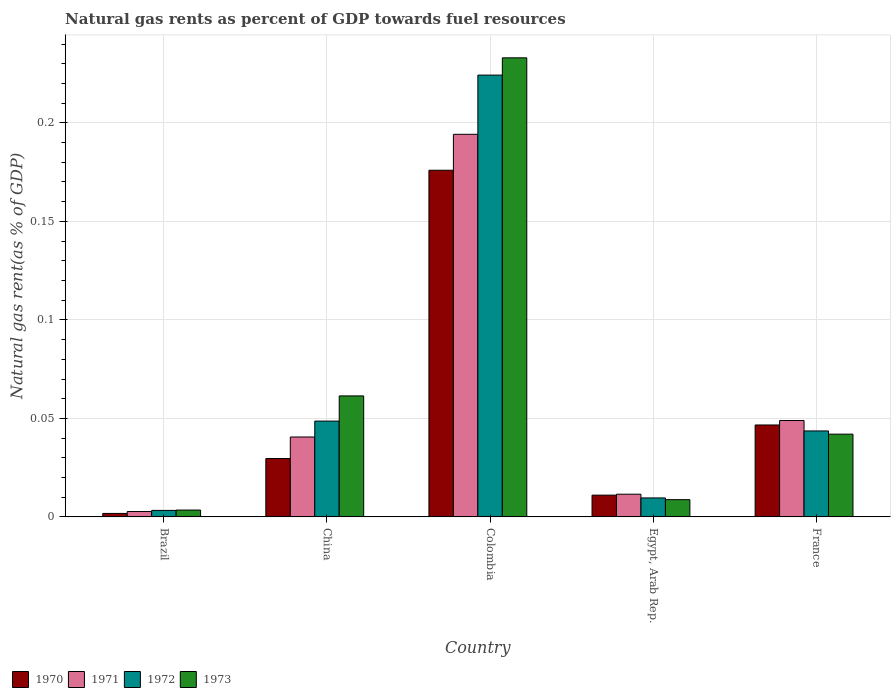How many different coloured bars are there?
Your answer should be very brief. 4. Are the number of bars on each tick of the X-axis equal?
Your response must be concise. Yes. How many bars are there on the 3rd tick from the right?
Ensure brevity in your answer.  4. What is the label of the 5th group of bars from the left?
Your answer should be very brief. France. What is the natural gas rent in 1972 in China?
Provide a succinct answer. 0.05. Across all countries, what is the maximum natural gas rent in 1972?
Your answer should be very brief. 0.22. Across all countries, what is the minimum natural gas rent in 1971?
Give a very brief answer. 0. In which country was the natural gas rent in 1970 maximum?
Give a very brief answer. Colombia. In which country was the natural gas rent in 1971 minimum?
Provide a short and direct response. Brazil. What is the total natural gas rent in 1970 in the graph?
Give a very brief answer. 0.27. What is the difference between the natural gas rent in 1970 in Brazil and that in France?
Offer a terse response. -0.04. What is the difference between the natural gas rent in 1971 in France and the natural gas rent in 1970 in Brazil?
Keep it short and to the point. 0.05. What is the average natural gas rent in 1970 per country?
Your answer should be compact. 0.05. What is the difference between the natural gas rent of/in 1971 and natural gas rent of/in 1973 in Egypt, Arab Rep.?
Offer a very short reply. 0. What is the ratio of the natural gas rent in 1972 in Egypt, Arab Rep. to that in France?
Provide a short and direct response. 0.22. Is the natural gas rent in 1973 in China less than that in Egypt, Arab Rep.?
Make the answer very short. No. What is the difference between the highest and the second highest natural gas rent in 1970?
Offer a terse response. 0.15. What is the difference between the highest and the lowest natural gas rent in 1973?
Offer a terse response. 0.23. In how many countries, is the natural gas rent in 1973 greater than the average natural gas rent in 1973 taken over all countries?
Your response must be concise. 1. Is the sum of the natural gas rent in 1972 in Egypt, Arab Rep. and France greater than the maximum natural gas rent in 1973 across all countries?
Your response must be concise. No. Is it the case that in every country, the sum of the natural gas rent in 1972 and natural gas rent in 1973 is greater than the sum of natural gas rent in 1970 and natural gas rent in 1971?
Give a very brief answer. No. What does the 4th bar from the left in Egypt, Arab Rep. represents?
Provide a short and direct response. 1973. What does the 4th bar from the right in Colombia represents?
Provide a succinct answer. 1970. Is it the case that in every country, the sum of the natural gas rent in 1972 and natural gas rent in 1973 is greater than the natural gas rent in 1971?
Provide a short and direct response. Yes. Are all the bars in the graph horizontal?
Offer a very short reply. No. Are the values on the major ticks of Y-axis written in scientific E-notation?
Your response must be concise. No. Does the graph contain any zero values?
Give a very brief answer. No. Where does the legend appear in the graph?
Provide a succinct answer. Bottom left. How are the legend labels stacked?
Give a very brief answer. Horizontal. What is the title of the graph?
Make the answer very short. Natural gas rents as percent of GDP towards fuel resources. Does "2000" appear as one of the legend labels in the graph?
Make the answer very short. No. What is the label or title of the Y-axis?
Keep it short and to the point. Natural gas rent(as % of GDP). What is the Natural gas rent(as % of GDP) of 1970 in Brazil?
Offer a terse response. 0. What is the Natural gas rent(as % of GDP) in 1971 in Brazil?
Your answer should be compact. 0. What is the Natural gas rent(as % of GDP) of 1972 in Brazil?
Provide a succinct answer. 0. What is the Natural gas rent(as % of GDP) in 1973 in Brazil?
Offer a terse response. 0. What is the Natural gas rent(as % of GDP) of 1970 in China?
Offer a terse response. 0.03. What is the Natural gas rent(as % of GDP) in 1971 in China?
Your response must be concise. 0.04. What is the Natural gas rent(as % of GDP) of 1972 in China?
Provide a succinct answer. 0.05. What is the Natural gas rent(as % of GDP) of 1973 in China?
Offer a terse response. 0.06. What is the Natural gas rent(as % of GDP) in 1970 in Colombia?
Your answer should be compact. 0.18. What is the Natural gas rent(as % of GDP) of 1971 in Colombia?
Provide a succinct answer. 0.19. What is the Natural gas rent(as % of GDP) in 1972 in Colombia?
Ensure brevity in your answer.  0.22. What is the Natural gas rent(as % of GDP) in 1973 in Colombia?
Your answer should be very brief. 0.23. What is the Natural gas rent(as % of GDP) in 1970 in Egypt, Arab Rep.?
Offer a very short reply. 0.01. What is the Natural gas rent(as % of GDP) in 1971 in Egypt, Arab Rep.?
Offer a very short reply. 0.01. What is the Natural gas rent(as % of GDP) in 1972 in Egypt, Arab Rep.?
Provide a short and direct response. 0.01. What is the Natural gas rent(as % of GDP) in 1973 in Egypt, Arab Rep.?
Offer a terse response. 0.01. What is the Natural gas rent(as % of GDP) of 1970 in France?
Keep it short and to the point. 0.05. What is the Natural gas rent(as % of GDP) of 1971 in France?
Offer a very short reply. 0.05. What is the Natural gas rent(as % of GDP) of 1972 in France?
Offer a very short reply. 0.04. What is the Natural gas rent(as % of GDP) of 1973 in France?
Give a very brief answer. 0.04. Across all countries, what is the maximum Natural gas rent(as % of GDP) in 1970?
Provide a short and direct response. 0.18. Across all countries, what is the maximum Natural gas rent(as % of GDP) of 1971?
Give a very brief answer. 0.19. Across all countries, what is the maximum Natural gas rent(as % of GDP) in 1972?
Ensure brevity in your answer.  0.22. Across all countries, what is the maximum Natural gas rent(as % of GDP) of 1973?
Keep it short and to the point. 0.23. Across all countries, what is the minimum Natural gas rent(as % of GDP) of 1970?
Your answer should be compact. 0. Across all countries, what is the minimum Natural gas rent(as % of GDP) in 1971?
Give a very brief answer. 0. Across all countries, what is the minimum Natural gas rent(as % of GDP) in 1972?
Ensure brevity in your answer.  0. Across all countries, what is the minimum Natural gas rent(as % of GDP) in 1973?
Your response must be concise. 0. What is the total Natural gas rent(as % of GDP) in 1970 in the graph?
Your answer should be very brief. 0.27. What is the total Natural gas rent(as % of GDP) of 1971 in the graph?
Make the answer very short. 0.3. What is the total Natural gas rent(as % of GDP) in 1972 in the graph?
Ensure brevity in your answer.  0.33. What is the total Natural gas rent(as % of GDP) in 1973 in the graph?
Keep it short and to the point. 0.35. What is the difference between the Natural gas rent(as % of GDP) of 1970 in Brazil and that in China?
Your answer should be compact. -0.03. What is the difference between the Natural gas rent(as % of GDP) of 1971 in Brazil and that in China?
Make the answer very short. -0.04. What is the difference between the Natural gas rent(as % of GDP) in 1972 in Brazil and that in China?
Your answer should be compact. -0.05. What is the difference between the Natural gas rent(as % of GDP) in 1973 in Brazil and that in China?
Provide a short and direct response. -0.06. What is the difference between the Natural gas rent(as % of GDP) in 1970 in Brazil and that in Colombia?
Offer a terse response. -0.17. What is the difference between the Natural gas rent(as % of GDP) in 1971 in Brazil and that in Colombia?
Offer a terse response. -0.19. What is the difference between the Natural gas rent(as % of GDP) of 1972 in Brazil and that in Colombia?
Provide a short and direct response. -0.22. What is the difference between the Natural gas rent(as % of GDP) of 1973 in Brazil and that in Colombia?
Provide a succinct answer. -0.23. What is the difference between the Natural gas rent(as % of GDP) in 1970 in Brazil and that in Egypt, Arab Rep.?
Make the answer very short. -0.01. What is the difference between the Natural gas rent(as % of GDP) of 1971 in Brazil and that in Egypt, Arab Rep.?
Make the answer very short. -0.01. What is the difference between the Natural gas rent(as % of GDP) in 1972 in Brazil and that in Egypt, Arab Rep.?
Offer a terse response. -0.01. What is the difference between the Natural gas rent(as % of GDP) in 1973 in Brazil and that in Egypt, Arab Rep.?
Your answer should be very brief. -0.01. What is the difference between the Natural gas rent(as % of GDP) of 1970 in Brazil and that in France?
Ensure brevity in your answer.  -0.04. What is the difference between the Natural gas rent(as % of GDP) of 1971 in Brazil and that in France?
Provide a succinct answer. -0.05. What is the difference between the Natural gas rent(as % of GDP) of 1972 in Brazil and that in France?
Ensure brevity in your answer.  -0.04. What is the difference between the Natural gas rent(as % of GDP) of 1973 in Brazil and that in France?
Provide a succinct answer. -0.04. What is the difference between the Natural gas rent(as % of GDP) of 1970 in China and that in Colombia?
Ensure brevity in your answer.  -0.15. What is the difference between the Natural gas rent(as % of GDP) of 1971 in China and that in Colombia?
Keep it short and to the point. -0.15. What is the difference between the Natural gas rent(as % of GDP) of 1972 in China and that in Colombia?
Make the answer very short. -0.18. What is the difference between the Natural gas rent(as % of GDP) of 1973 in China and that in Colombia?
Make the answer very short. -0.17. What is the difference between the Natural gas rent(as % of GDP) of 1970 in China and that in Egypt, Arab Rep.?
Your response must be concise. 0.02. What is the difference between the Natural gas rent(as % of GDP) of 1971 in China and that in Egypt, Arab Rep.?
Offer a very short reply. 0.03. What is the difference between the Natural gas rent(as % of GDP) of 1972 in China and that in Egypt, Arab Rep.?
Provide a succinct answer. 0.04. What is the difference between the Natural gas rent(as % of GDP) of 1973 in China and that in Egypt, Arab Rep.?
Offer a very short reply. 0.05. What is the difference between the Natural gas rent(as % of GDP) in 1970 in China and that in France?
Offer a terse response. -0.02. What is the difference between the Natural gas rent(as % of GDP) of 1971 in China and that in France?
Provide a succinct answer. -0.01. What is the difference between the Natural gas rent(as % of GDP) in 1972 in China and that in France?
Your answer should be compact. 0.01. What is the difference between the Natural gas rent(as % of GDP) of 1973 in China and that in France?
Your answer should be compact. 0.02. What is the difference between the Natural gas rent(as % of GDP) in 1970 in Colombia and that in Egypt, Arab Rep.?
Provide a succinct answer. 0.16. What is the difference between the Natural gas rent(as % of GDP) of 1971 in Colombia and that in Egypt, Arab Rep.?
Your answer should be compact. 0.18. What is the difference between the Natural gas rent(as % of GDP) of 1972 in Colombia and that in Egypt, Arab Rep.?
Give a very brief answer. 0.21. What is the difference between the Natural gas rent(as % of GDP) of 1973 in Colombia and that in Egypt, Arab Rep.?
Provide a succinct answer. 0.22. What is the difference between the Natural gas rent(as % of GDP) of 1970 in Colombia and that in France?
Offer a very short reply. 0.13. What is the difference between the Natural gas rent(as % of GDP) in 1971 in Colombia and that in France?
Offer a very short reply. 0.15. What is the difference between the Natural gas rent(as % of GDP) of 1972 in Colombia and that in France?
Provide a short and direct response. 0.18. What is the difference between the Natural gas rent(as % of GDP) in 1973 in Colombia and that in France?
Your answer should be very brief. 0.19. What is the difference between the Natural gas rent(as % of GDP) of 1970 in Egypt, Arab Rep. and that in France?
Offer a very short reply. -0.04. What is the difference between the Natural gas rent(as % of GDP) in 1971 in Egypt, Arab Rep. and that in France?
Your response must be concise. -0.04. What is the difference between the Natural gas rent(as % of GDP) in 1972 in Egypt, Arab Rep. and that in France?
Offer a very short reply. -0.03. What is the difference between the Natural gas rent(as % of GDP) in 1973 in Egypt, Arab Rep. and that in France?
Provide a succinct answer. -0.03. What is the difference between the Natural gas rent(as % of GDP) in 1970 in Brazil and the Natural gas rent(as % of GDP) in 1971 in China?
Your response must be concise. -0.04. What is the difference between the Natural gas rent(as % of GDP) in 1970 in Brazil and the Natural gas rent(as % of GDP) in 1972 in China?
Give a very brief answer. -0.05. What is the difference between the Natural gas rent(as % of GDP) in 1970 in Brazil and the Natural gas rent(as % of GDP) in 1973 in China?
Provide a short and direct response. -0.06. What is the difference between the Natural gas rent(as % of GDP) of 1971 in Brazil and the Natural gas rent(as % of GDP) of 1972 in China?
Your answer should be compact. -0.05. What is the difference between the Natural gas rent(as % of GDP) in 1971 in Brazil and the Natural gas rent(as % of GDP) in 1973 in China?
Keep it short and to the point. -0.06. What is the difference between the Natural gas rent(as % of GDP) of 1972 in Brazil and the Natural gas rent(as % of GDP) of 1973 in China?
Your answer should be very brief. -0.06. What is the difference between the Natural gas rent(as % of GDP) in 1970 in Brazil and the Natural gas rent(as % of GDP) in 1971 in Colombia?
Your response must be concise. -0.19. What is the difference between the Natural gas rent(as % of GDP) in 1970 in Brazil and the Natural gas rent(as % of GDP) in 1972 in Colombia?
Offer a terse response. -0.22. What is the difference between the Natural gas rent(as % of GDP) of 1970 in Brazil and the Natural gas rent(as % of GDP) of 1973 in Colombia?
Keep it short and to the point. -0.23. What is the difference between the Natural gas rent(as % of GDP) of 1971 in Brazil and the Natural gas rent(as % of GDP) of 1972 in Colombia?
Give a very brief answer. -0.22. What is the difference between the Natural gas rent(as % of GDP) in 1971 in Brazil and the Natural gas rent(as % of GDP) in 1973 in Colombia?
Offer a very short reply. -0.23. What is the difference between the Natural gas rent(as % of GDP) of 1972 in Brazil and the Natural gas rent(as % of GDP) of 1973 in Colombia?
Give a very brief answer. -0.23. What is the difference between the Natural gas rent(as % of GDP) of 1970 in Brazil and the Natural gas rent(as % of GDP) of 1971 in Egypt, Arab Rep.?
Your response must be concise. -0.01. What is the difference between the Natural gas rent(as % of GDP) in 1970 in Brazil and the Natural gas rent(as % of GDP) in 1972 in Egypt, Arab Rep.?
Keep it short and to the point. -0.01. What is the difference between the Natural gas rent(as % of GDP) of 1970 in Brazil and the Natural gas rent(as % of GDP) of 1973 in Egypt, Arab Rep.?
Ensure brevity in your answer.  -0.01. What is the difference between the Natural gas rent(as % of GDP) of 1971 in Brazil and the Natural gas rent(as % of GDP) of 1972 in Egypt, Arab Rep.?
Your answer should be very brief. -0.01. What is the difference between the Natural gas rent(as % of GDP) in 1971 in Brazil and the Natural gas rent(as % of GDP) in 1973 in Egypt, Arab Rep.?
Your answer should be compact. -0.01. What is the difference between the Natural gas rent(as % of GDP) in 1972 in Brazil and the Natural gas rent(as % of GDP) in 1973 in Egypt, Arab Rep.?
Give a very brief answer. -0.01. What is the difference between the Natural gas rent(as % of GDP) of 1970 in Brazil and the Natural gas rent(as % of GDP) of 1971 in France?
Provide a short and direct response. -0.05. What is the difference between the Natural gas rent(as % of GDP) in 1970 in Brazil and the Natural gas rent(as % of GDP) in 1972 in France?
Your answer should be very brief. -0.04. What is the difference between the Natural gas rent(as % of GDP) of 1970 in Brazil and the Natural gas rent(as % of GDP) of 1973 in France?
Make the answer very short. -0.04. What is the difference between the Natural gas rent(as % of GDP) in 1971 in Brazil and the Natural gas rent(as % of GDP) in 1972 in France?
Your response must be concise. -0.04. What is the difference between the Natural gas rent(as % of GDP) of 1971 in Brazil and the Natural gas rent(as % of GDP) of 1973 in France?
Provide a succinct answer. -0.04. What is the difference between the Natural gas rent(as % of GDP) in 1972 in Brazil and the Natural gas rent(as % of GDP) in 1973 in France?
Make the answer very short. -0.04. What is the difference between the Natural gas rent(as % of GDP) in 1970 in China and the Natural gas rent(as % of GDP) in 1971 in Colombia?
Make the answer very short. -0.16. What is the difference between the Natural gas rent(as % of GDP) in 1970 in China and the Natural gas rent(as % of GDP) in 1972 in Colombia?
Keep it short and to the point. -0.19. What is the difference between the Natural gas rent(as % of GDP) in 1970 in China and the Natural gas rent(as % of GDP) in 1973 in Colombia?
Make the answer very short. -0.2. What is the difference between the Natural gas rent(as % of GDP) of 1971 in China and the Natural gas rent(as % of GDP) of 1972 in Colombia?
Keep it short and to the point. -0.18. What is the difference between the Natural gas rent(as % of GDP) of 1971 in China and the Natural gas rent(as % of GDP) of 1973 in Colombia?
Your answer should be very brief. -0.19. What is the difference between the Natural gas rent(as % of GDP) of 1972 in China and the Natural gas rent(as % of GDP) of 1973 in Colombia?
Give a very brief answer. -0.18. What is the difference between the Natural gas rent(as % of GDP) in 1970 in China and the Natural gas rent(as % of GDP) in 1971 in Egypt, Arab Rep.?
Provide a succinct answer. 0.02. What is the difference between the Natural gas rent(as % of GDP) of 1970 in China and the Natural gas rent(as % of GDP) of 1972 in Egypt, Arab Rep.?
Your answer should be compact. 0.02. What is the difference between the Natural gas rent(as % of GDP) of 1970 in China and the Natural gas rent(as % of GDP) of 1973 in Egypt, Arab Rep.?
Provide a short and direct response. 0.02. What is the difference between the Natural gas rent(as % of GDP) of 1971 in China and the Natural gas rent(as % of GDP) of 1972 in Egypt, Arab Rep.?
Offer a terse response. 0.03. What is the difference between the Natural gas rent(as % of GDP) in 1971 in China and the Natural gas rent(as % of GDP) in 1973 in Egypt, Arab Rep.?
Keep it short and to the point. 0.03. What is the difference between the Natural gas rent(as % of GDP) of 1972 in China and the Natural gas rent(as % of GDP) of 1973 in Egypt, Arab Rep.?
Make the answer very short. 0.04. What is the difference between the Natural gas rent(as % of GDP) in 1970 in China and the Natural gas rent(as % of GDP) in 1971 in France?
Offer a terse response. -0.02. What is the difference between the Natural gas rent(as % of GDP) of 1970 in China and the Natural gas rent(as % of GDP) of 1972 in France?
Offer a terse response. -0.01. What is the difference between the Natural gas rent(as % of GDP) of 1970 in China and the Natural gas rent(as % of GDP) of 1973 in France?
Offer a terse response. -0.01. What is the difference between the Natural gas rent(as % of GDP) in 1971 in China and the Natural gas rent(as % of GDP) in 1972 in France?
Give a very brief answer. -0. What is the difference between the Natural gas rent(as % of GDP) of 1971 in China and the Natural gas rent(as % of GDP) of 1973 in France?
Offer a terse response. -0. What is the difference between the Natural gas rent(as % of GDP) of 1972 in China and the Natural gas rent(as % of GDP) of 1973 in France?
Give a very brief answer. 0.01. What is the difference between the Natural gas rent(as % of GDP) of 1970 in Colombia and the Natural gas rent(as % of GDP) of 1971 in Egypt, Arab Rep.?
Your answer should be compact. 0.16. What is the difference between the Natural gas rent(as % of GDP) in 1970 in Colombia and the Natural gas rent(as % of GDP) in 1972 in Egypt, Arab Rep.?
Your answer should be compact. 0.17. What is the difference between the Natural gas rent(as % of GDP) in 1970 in Colombia and the Natural gas rent(as % of GDP) in 1973 in Egypt, Arab Rep.?
Offer a very short reply. 0.17. What is the difference between the Natural gas rent(as % of GDP) in 1971 in Colombia and the Natural gas rent(as % of GDP) in 1972 in Egypt, Arab Rep.?
Provide a short and direct response. 0.18. What is the difference between the Natural gas rent(as % of GDP) in 1971 in Colombia and the Natural gas rent(as % of GDP) in 1973 in Egypt, Arab Rep.?
Provide a succinct answer. 0.19. What is the difference between the Natural gas rent(as % of GDP) in 1972 in Colombia and the Natural gas rent(as % of GDP) in 1973 in Egypt, Arab Rep.?
Ensure brevity in your answer.  0.22. What is the difference between the Natural gas rent(as % of GDP) in 1970 in Colombia and the Natural gas rent(as % of GDP) in 1971 in France?
Offer a terse response. 0.13. What is the difference between the Natural gas rent(as % of GDP) in 1970 in Colombia and the Natural gas rent(as % of GDP) in 1972 in France?
Your response must be concise. 0.13. What is the difference between the Natural gas rent(as % of GDP) in 1970 in Colombia and the Natural gas rent(as % of GDP) in 1973 in France?
Make the answer very short. 0.13. What is the difference between the Natural gas rent(as % of GDP) in 1971 in Colombia and the Natural gas rent(as % of GDP) in 1972 in France?
Make the answer very short. 0.15. What is the difference between the Natural gas rent(as % of GDP) of 1971 in Colombia and the Natural gas rent(as % of GDP) of 1973 in France?
Your response must be concise. 0.15. What is the difference between the Natural gas rent(as % of GDP) of 1972 in Colombia and the Natural gas rent(as % of GDP) of 1973 in France?
Offer a terse response. 0.18. What is the difference between the Natural gas rent(as % of GDP) in 1970 in Egypt, Arab Rep. and the Natural gas rent(as % of GDP) in 1971 in France?
Make the answer very short. -0.04. What is the difference between the Natural gas rent(as % of GDP) in 1970 in Egypt, Arab Rep. and the Natural gas rent(as % of GDP) in 1972 in France?
Your response must be concise. -0.03. What is the difference between the Natural gas rent(as % of GDP) in 1970 in Egypt, Arab Rep. and the Natural gas rent(as % of GDP) in 1973 in France?
Give a very brief answer. -0.03. What is the difference between the Natural gas rent(as % of GDP) of 1971 in Egypt, Arab Rep. and the Natural gas rent(as % of GDP) of 1972 in France?
Your response must be concise. -0.03. What is the difference between the Natural gas rent(as % of GDP) in 1971 in Egypt, Arab Rep. and the Natural gas rent(as % of GDP) in 1973 in France?
Your answer should be very brief. -0.03. What is the difference between the Natural gas rent(as % of GDP) in 1972 in Egypt, Arab Rep. and the Natural gas rent(as % of GDP) in 1973 in France?
Keep it short and to the point. -0.03. What is the average Natural gas rent(as % of GDP) in 1970 per country?
Provide a short and direct response. 0.05. What is the average Natural gas rent(as % of GDP) in 1971 per country?
Give a very brief answer. 0.06. What is the average Natural gas rent(as % of GDP) of 1972 per country?
Give a very brief answer. 0.07. What is the average Natural gas rent(as % of GDP) of 1973 per country?
Your answer should be compact. 0.07. What is the difference between the Natural gas rent(as % of GDP) in 1970 and Natural gas rent(as % of GDP) in 1971 in Brazil?
Give a very brief answer. -0. What is the difference between the Natural gas rent(as % of GDP) in 1970 and Natural gas rent(as % of GDP) in 1972 in Brazil?
Your answer should be very brief. -0. What is the difference between the Natural gas rent(as % of GDP) in 1970 and Natural gas rent(as % of GDP) in 1973 in Brazil?
Offer a very short reply. -0. What is the difference between the Natural gas rent(as % of GDP) of 1971 and Natural gas rent(as % of GDP) of 1972 in Brazil?
Keep it short and to the point. -0. What is the difference between the Natural gas rent(as % of GDP) in 1971 and Natural gas rent(as % of GDP) in 1973 in Brazil?
Provide a short and direct response. -0. What is the difference between the Natural gas rent(as % of GDP) in 1972 and Natural gas rent(as % of GDP) in 1973 in Brazil?
Make the answer very short. -0. What is the difference between the Natural gas rent(as % of GDP) of 1970 and Natural gas rent(as % of GDP) of 1971 in China?
Your answer should be compact. -0.01. What is the difference between the Natural gas rent(as % of GDP) in 1970 and Natural gas rent(as % of GDP) in 1972 in China?
Keep it short and to the point. -0.02. What is the difference between the Natural gas rent(as % of GDP) in 1970 and Natural gas rent(as % of GDP) in 1973 in China?
Provide a short and direct response. -0.03. What is the difference between the Natural gas rent(as % of GDP) of 1971 and Natural gas rent(as % of GDP) of 1972 in China?
Make the answer very short. -0.01. What is the difference between the Natural gas rent(as % of GDP) of 1971 and Natural gas rent(as % of GDP) of 1973 in China?
Provide a short and direct response. -0.02. What is the difference between the Natural gas rent(as % of GDP) of 1972 and Natural gas rent(as % of GDP) of 1973 in China?
Your answer should be very brief. -0.01. What is the difference between the Natural gas rent(as % of GDP) of 1970 and Natural gas rent(as % of GDP) of 1971 in Colombia?
Your response must be concise. -0.02. What is the difference between the Natural gas rent(as % of GDP) in 1970 and Natural gas rent(as % of GDP) in 1972 in Colombia?
Keep it short and to the point. -0.05. What is the difference between the Natural gas rent(as % of GDP) of 1970 and Natural gas rent(as % of GDP) of 1973 in Colombia?
Offer a terse response. -0.06. What is the difference between the Natural gas rent(as % of GDP) in 1971 and Natural gas rent(as % of GDP) in 1972 in Colombia?
Give a very brief answer. -0.03. What is the difference between the Natural gas rent(as % of GDP) in 1971 and Natural gas rent(as % of GDP) in 1973 in Colombia?
Your answer should be compact. -0.04. What is the difference between the Natural gas rent(as % of GDP) in 1972 and Natural gas rent(as % of GDP) in 1973 in Colombia?
Offer a terse response. -0.01. What is the difference between the Natural gas rent(as % of GDP) in 1970 and Natural gas rent(as % of GDP) in 1971 in Egypt, Arab Rep.?
Give a very brief answer. -0. What is the difference between the Natural gas rent(as % of GDP) in 1970 and Natural gas rent(as % of GDP) in 1972 in Egypt, Arab Rep.?
Provide a succinct answer. 0. What is the difference between the Natural gas rent(as % of GDP) in 1970 and Natural gas rent(as % of GDP) in 1973 in Egypt, Arab Rep.?
Your answer should be compact. 0. What is the difference between the Natural gas rent(as % of GDP) of 1971 and Natural gas rent(as % of GDP) of 1972 in Egypt, Arab Rep.?
Provide a succinct answer. 0. What is the difference between the Natural gas rent(as % of GDP) of 1971 and Natural gas rent(as % of GDP) of 1973 in Egypt, Arab Rep.?
Offer a terse response. 0. What is the difference between the Natural gas rent(as % of GDP) in 1972 and Natural gas rent(as % of GDP) in 1973 in Egypt, Arab Rep.?
Offer a terse response. 0. What is the difference between the Natural gas rent(as % of GDP) of 1970 and Natural gas rent(as % of GDP) of 1971 in France?
Provide a succinct answer. -0. What is the difference between the Natural gas rent(as % of GDP) in 1970 and Natural gas rent(as % of GDP) in 1972 in France?
Make the answer very short. 0. What is the difference between the Natural gas rent(as % of GDP) in 1970 and Natural gas rent(as % of GDP) in 1973 in France?
Keep it short and to the point. 0. What is the difference between the Natural gas rent(as % of GDP) of 1971 and Natural gas rent(as % of GDP) of 1972 in France?
Provide a succinct answer. 0.01. What is the difference between the Natural gas rent(as % of GDP) of 1971 and Natural gas rent(as % of GDP) of 1973 in France?
Your answer should be very brief. 0.01. What is the difference between the Natural gas rent(as % of GDP) in 1972 and Natural gas rent(as % of GDP) in 1973 in France?
Make the answer very short. 0. What is the ratio of the Natural gas rent(as % of GDP) in 1971 in Brazil to that in China?
Your answer should be compact. 0.07. What is the ratio of the Natural gas rent(as % of GDP) in 1972 in Brazil to that in China?
Give a very brief answer. 0.07. What is the ratio of the Natural gas rent(as % of GDP) of 1973 in Brazil to that in China?
Ensure brevity in your answer.  0.06. What is the ratio of the Natural gas rent(as % of GDP) in 1970 in Brazil to that in Colombia?
Provide a short and direct response. 0.01. What is the ratio of the Natural gas rent(as % of GDP) in 1971 in Brazil to that in Colombia?
Keep it short and to the point. 0.01. What is the ratio of the Natural gas rent(as % of GDP) of 1972 in Brazil to that in Colombia?
Provide a succinct answer. 0.01. What is the ratio of the Natural gas rent(as % of GDP) in 1973 in Brazil to that in Colombia?
Your answer should be compact. 0.01. What is the ratio of the Natural gas rent(as % of GDP) in 1970 in Brazil to that in Egypt, Arab Rep.?
Offer a very short reply. 0.16. What is the ratio of the Natural gas rent(as % of GDP) in 1971 in Brazil to that in Egypt, Arab Rep.?
Ensure brevity in your answer.  0.24. What is the ratio of the Natural gas rent(as % of GDP) of 1972 in Brazil to that in Egypt, Arab Rep.?
Make the answer very short. 0.34. What is the ratio of the Natural gas rent(as % of GDP) in 1973 in Brazil to that in Egypt, Arab Rep.?
Offer a terse response. 0.4. What is the ratio of the Natural gas rent(as % of GDP) of 1970 in Brazil to that in France?
Make the answer very short. 0.04. What is the ratio of the Natural gas rent(as % of GDP) of 1971 in Brazil to that in France?
Provide a short and direct response. 0.06. What is the ratio of the Natural gas rent(as % of GDP) in 1972 in Brazil to that in France?
Provide a succinct answer. 0.08. What is the ratio of the Natural gas rent(as % of GDP) in 1973 in Brazil to that in France?
Your response must be concise. 0.08. What is the ratio of the Natural gas rent(as % of GDP) in 1970 in China to that in Colombia?
Your answer should be compact. 0.17. What is the ratio of the Natural gas rent(as % of GDP) in 1971 in China to that in Colombia?
Your answer should be very brief. 0.21. What is the ratio of the Natural gas rent(as % of GDP) in 1972 in China to that in Colombia?
Your answer should be compact. 0.22. What is the ratio of the Natural gas rent(as % of GDP) in 1973 in China to that in Colombia?
Offer a very short reply. 0.26. What is the ratio of the Natural gas rent(as % of GDP) of 1970 in China to that in Egypt, Arab Rep.?
Provide a succinct answer. 2.68. What is the ratio of the Natural gas rent(as % of GDP) of 1971 in China to that in Egypt, Arab Rep.?
Make the answer very short. 3.52. What is the ratio of the Natural gas rent(as % of GDP) in 1972 in China to that in Egypt, Arab Rep.?
Your answer should be very brief. 5.04. What is the ratio of the Natural gas rent(as % of GDP) of 1973 in China to that in Egypt, Arab Rep.?
Provide a succinct answer. 7.01. What is the ratio of the Natural gas rent(as % of GDP) of 1970 in China to that in France?
Offer a very short reply. 0.64. What is the ratio of the Natural gas rent(as % of GDP) of 1971 in China to that in France?
Give a very brief answer. 0.83. What is the ratio of the Natural gas rent(as % of GDP) of 1972 in China to that in France?
Provide a succinct answer. 1.11. What is the ratio of the Natural gas rent(as % of GDP) of 1973 in China to that in France?
Your answer should be very brief. 1.46. What is the ratio of the Natural gas rent(as % of GDP) in 1970 in Colombia to that in Egypt, Arab Rep.?
Provide a short and direct response. 15.9. What is the ratio of the Natural gas rent(as % of GDP) in 1971 in Colombia to that in Egypt, Arab Rep.?
Ensure brevity in your answer.  16.84. What is the ratio of the Natural gas rent(as % of GDP) of 1972 in Colombia to that in Egypt, Arab Rep.?
Provide a succinct answer. 23.25. What is the ratio of the Natural gas rent(as % of GDP) in 1973 in Colombia to that in Egypt, Arab Rep.?
Offer a very short reply. 26.6. What is the ratio of the Natural gas rent(as % of GDP) in 1970 in Colombia to that in France?
Your answer should be very brief. 3.77. What is the ratio of the Natural gas rent(as % of GDP) in 1971 in Colombia to that in France?
Offer a terse response. 3.97. What is the ratio of the Natural gas rent(as % of GDP) of 1972 in Colombia to that in France?
Your answer should be compact. 5.14. What is the ratio of the Natural gas rent(as % of GDP) in 1973 in Colombia to that in France?
Offer a terse response. 5.55. What is the ratio of the Natural gas rent(as % of GDP) of 1970 in Egypt, Arab Rep. to that in France?
Your answer should be compact. 0.24. What is the ratio of the Natural gas rent(as % of GDP) of 1971 in Egypt, Arab Rep. to that in France?
Give a very brief answer. 0.24. What is the ratio of the Natural gas rent(as % of GDP) of 1972 in Egypt, Arab Rep. to that in France?
Ensure brevity in your answer.  0.22. What is the ratio of the Natural gas rent(as % of GDP) of 1973 in Egypt, Arab Rep. to that in France?
Provide a short and direct response. 0.21. What is the difference between the highest and the second highest Natural gas rent(as % of GDP) in 1970?
Make the answer very short. 0.13. What is the difference between the highest and the second highest Natural gas rent(as % of GDP) of 1971?
Provide a short and direct response. 0.15. What is the difference between the highest and the second highest Natural gas rent(as % of GDP) of 1972?
Ensure brevity in your answer.  0.18. What is the difference between the highest and the second highest Natural gas rent(as % of GDP) in 1973?
Make the answer very short. 0.17. What is the difference between the highest and the lowest Natural gas rent(as % of GDP) in 1970?
Provide a succinct answer. 0.17. What is the difference between the highest and the lowest Natural gas rent(as % of GDP) in 1971?
Make the answer very short. 0.19. What is the difference between the highest and the lowest Natural gas rent(as % of GDP) of 1972?
Provide a short and direct response. 0.22. What is the difference between the highest and the lowest Natural gas rent(as % of GDP) in 1973?
Offer a very short reply. 0.23. 